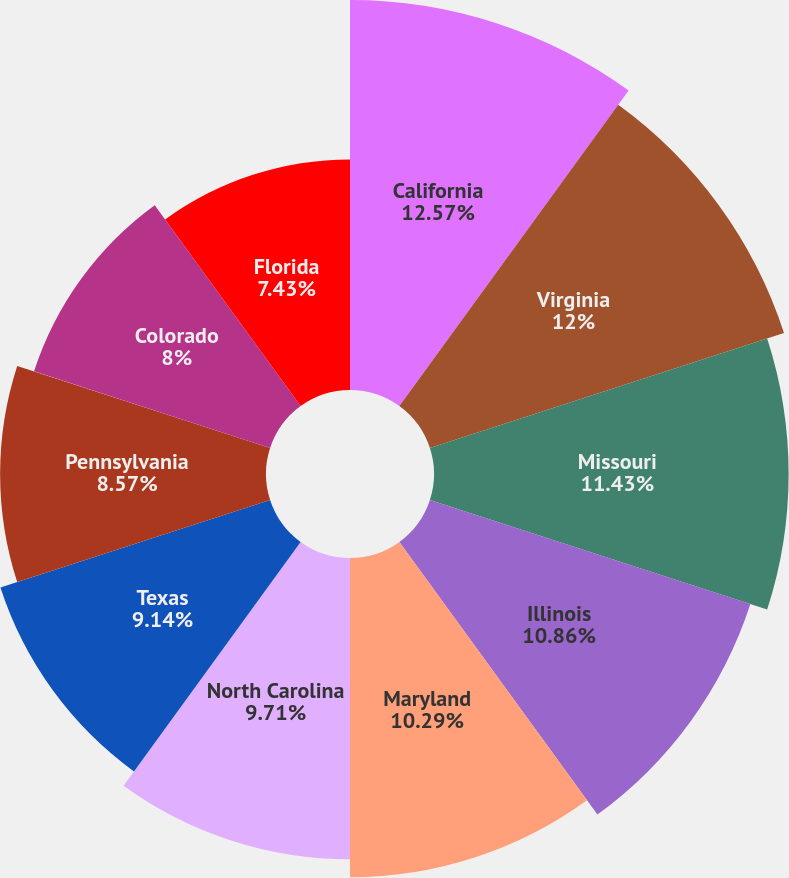Convert chart to OTSL. <chart><loc_0><loc_0><loc_500><loc_500><pie_chart><fcel>California<fcel>Virginia<fcel>Missouri<fcel>Illinois<fcel>Maryland<fcel>North Carolina<fcel>Texas<fcel>Pennsylvania<fcel>Colorado<fcel>Florida<nl><fcel>12.57%<fcel>12.0%<fcel>11.43%<fcel>10.86%<fcel>10.29%<fcel>9.71%<fcel>9.14%<fcel>8.57%<fcel>8.0%<fcel>7.43%<nl></chart> 